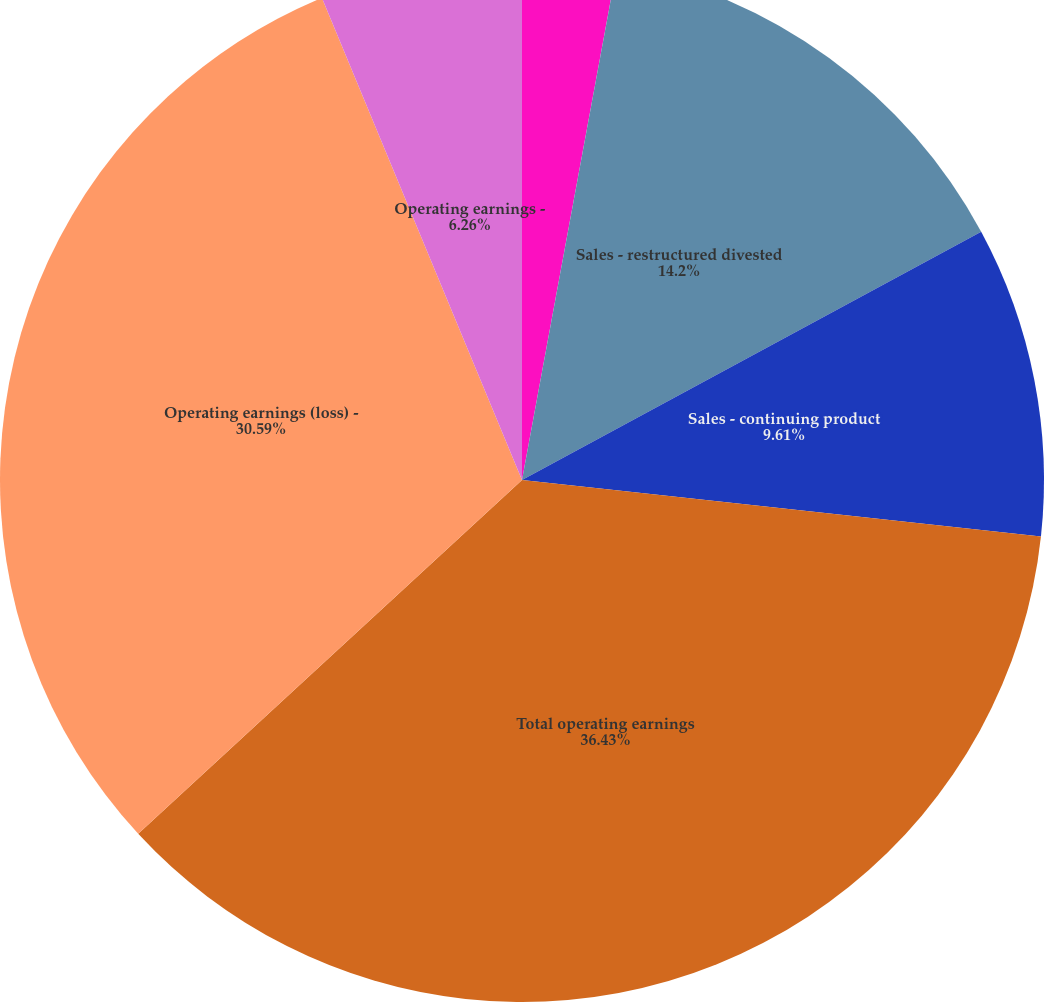Convert chart. <chart><loc_0><loc_0><loc_500><loc_500><pie_chart><fcel>Total external sales<fcel>Sales - restructured divested<fcel>Sales - continuing product<fcel>Total operating earnings<fcel>Operating earnings (loss) -<fcel>Operating earnings -<nl><fcel>2.91%<fcel>14.2%<fcel>9.61%<fcel>36.42%<fcel>30.59%<fcel>6.26%<nl></chart> 